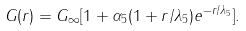<formula> <loc_0><loc_0><loc_500><loc_500>G ( r ) = G _ { \infty } [ 1 + \alpha _ { 5 } ( 1 + r / \lambda _ { 5 } ) e ^ { - r / \lambda _ { 5 } } ] .</formula> 